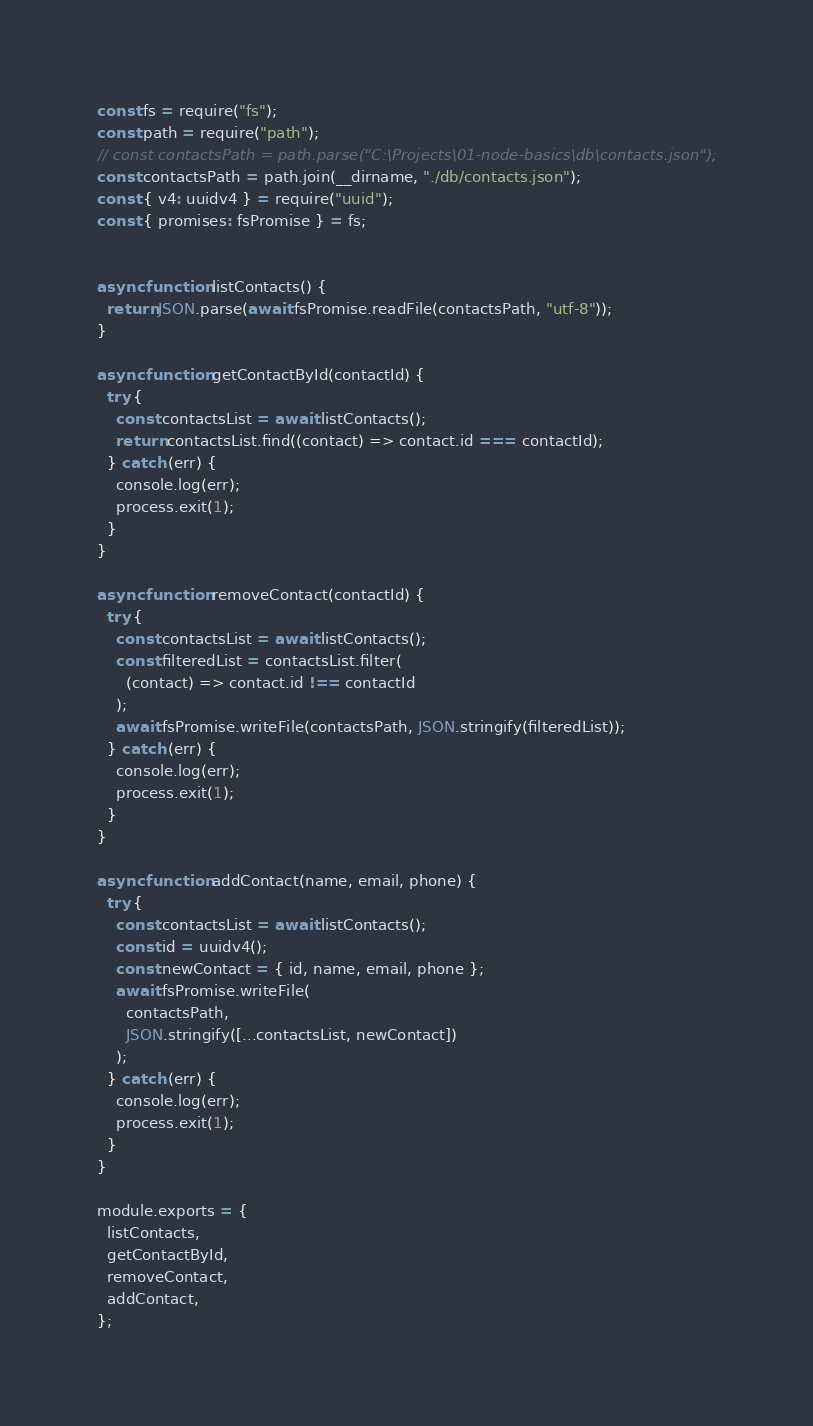<code> <loc_0><loc_0><loc_500><loc_500><_JavaScript_>const fs = require("fs");
const path = require("path");
// const contactsPath = path.parse("C:\Projects\01-node-basics\db\contacts.json");
const contactsPath = path.join(__dirname, "./db/contacts.json");
const { v4: uuidv4 } = require("uuid");
const { promises: fsPromise } = fs;


async function listContacts() {
  return JSON.parse(await fsPromise.readFile(contactsPath, "utf-8"));
}

async function getContactById(contactId) {
  try {
    const contactsList = await listContacts();
    return contactsList.find((contact) => contact.id === contactId);
  } catch (err) {
    console.log(err);
    process.exit(1);
  }
}

async function removeContact(contactId) {
  try {
    const contactsList = await listContacts();
    const filteredList = contactsList.filter(
      (contact) => contact.id !== contactId
    );
    await fsPromise.writeFile(contactsPath, JSON.stringify(filteredList));
  } catch (err) {
    console.log(err);
    process.exit(1);
  }
}

async function addContact(name, email, phone) {
  try {
    const contactsList = await listContacts();
    const id = uuidv4();
    const newContact = { id, name, email, phone };
    await fsPromise.writeFile(
      contactsPath,
      JSON.stringify([...contactsList, newContact])
    );
  } catch (err) {
    console.log(err);
    process.exit(1);
  }
}

module.exports = {
  listContacts,
  getContactById,
  removeContact,
  addContact,
};</code> 